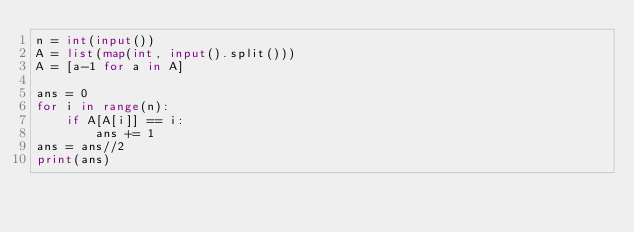Convert code to text. <code><loc_0><loc_0><loc_500><loc_500><_Python_>n = int(input())
A = list(map(int, input().split()))
A = [a-1 for a in A]

ans = 0
for i in range(n):
    if A[A[i]] == i:
        ans += 1
ans = ans//2
print(ans)
</code> 